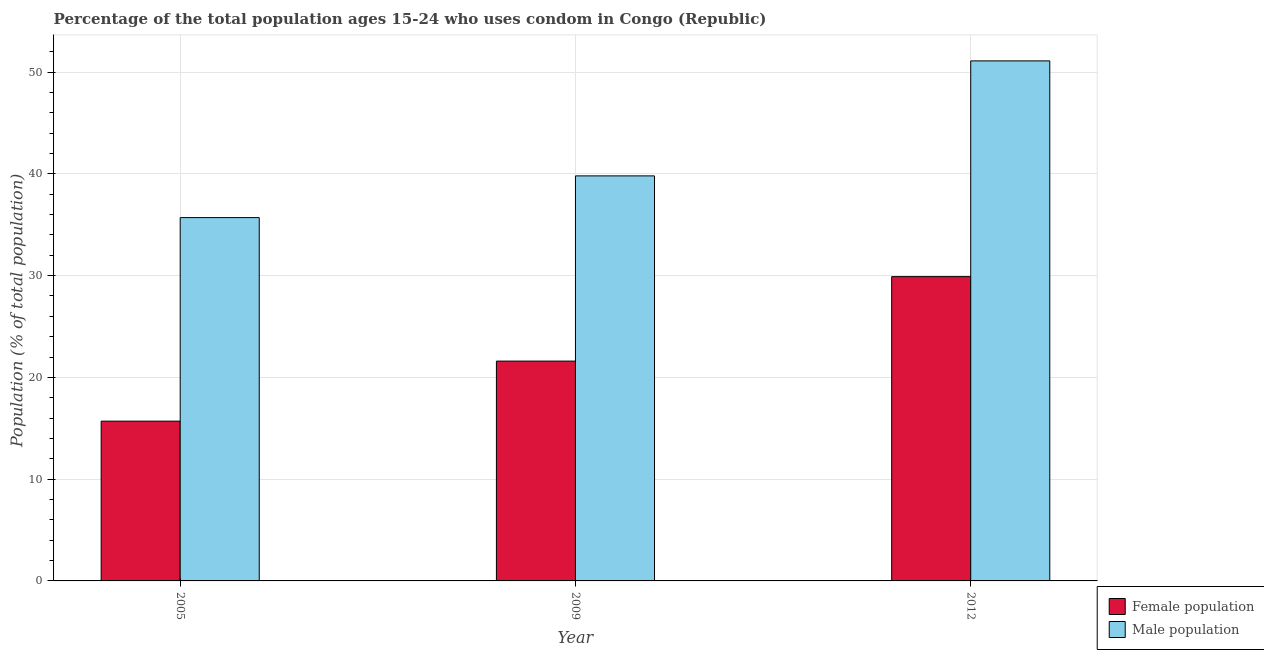How many different coloured bars are there?
Make the answer very short. 2. How many groups of bars are there?
Make the answer very short. 3. Are the number of bars per tick equal to the number of legend labels?
Ensure brevity in your answer.  Yes. Are the number of bars on each tick of the X-axis equal?
Your answer should be compact. Yes. How many bars are there on the 1st tick from the right?
Your answer should be very brief. 2. What is the male population in 2005?
Your answer should be very brief. 35.7. Across all years, what is the maximum female population?
Your response must be concise. 29.9. Across all years, what is the minimum male population?
Offer a terse response. 35.7. What is the total male population in the graph?
Your answer should be very brief. 126.6. What is the difference between the female population in 2009 and that in 2012?
Provide a succinct answer. -8.3. What is the difference between the female population in 2009 and the male population in 2005?
Offer a terse response. 5.9. What is the average male population per year?
Your answer should be compact. 42.2. In how many years, is the female population greater than 8 %?
Your answer should be very brief. 3. What is the ratio of the male population in 2005 to that in 2012?
Ensure brevity in your answer.  0.7. Is the difference between the female population in 2005 and 2009 greater than the difference between the male population in 2005 and 2009?
Give a very brief answer. No. What is the difference between the highest and the second highest male population?
Offer a terse response. 11.3. In how many years, is the male population greater than the average male population taken over all years?
Provide a short and direct response. 1. What does the 2nd bar from the left in 2012 represents?
Your answer should be compact. Male population. What does the 1st bar from the right in 2005 represents?
Give a very brief answer. Male population. How many bars are there?
Make the answer very short. 6. Are all the bars in the graph horizontal?
Your answer should be very brief. No. How many years are there in the graph?
Provide a succinct answer. 3. Are the values on the major ticks of Y-axis written in scientific E-notation?
Give a very brief answer. No. Does the graph contain any zero values?
Your answer should be compact. No. How many legend labels are there?
Your answer should be very brief. 2. How are the legend labels stacked?
Make the answer very short. Vertical. What is the title of the graph?
Offer a terse response. Percentage of the total population ages 15-24 who uses condom in Congo (Republic). What is the label or title of the X-axis?
Make the answer very short. Year. What is the label or title of the Y-axis?
Provide a short and direct response. Population (% of total population) . What is the Population (% of total population)  of Male population in 2005?
Make the answer very short. 35.7. What is the Population (% of total population)  of Female population in 2009?
Ensure brevity in your answer.  21.6. What is the Population (% of total population)  in Male population in 2009?
Offer a very short reply. 39.8. What is the Population (% of total population)  in Female population in 2012?
Provide a short and direct response. 29.9. What is the Population (% of total population)  in Male population in 2012?
Provide a succinct answer. 51.1. Across all years, what is the maximum Population (% of total population)  in Female population?
Keep it short and to the point. 29.9. Across all years, what is the maximum Population (% of total population)  of Male population?
Your answer should be very brief. 51.1. Across all years, what is the minimum Population (% of total population)  in Male population?
Provide a short and direct response. 35.7. What is the total Population (% of total population)  of Female population in the graph?
Your response must be concise. 67.2. What is the total Population (% of total population)  of Male population in the graph?
Provide a succinct answer. 126.6. What is the difference between the Population (% of total population)  of Female population in 2005 and that in 2009?
Keep it short and to the point. -5.9. What is the difference between the Population (% of total population)  of Male population in 2005 and that in 2009?
Your answer should be compact. -4.1. What is the difference between the Population (% of total population)  of Male population in 2005 and that in 2012?
Make the answer very short. -15.4. What is the difference between the Population (% of total population)  of Female population in 2005 and the Population (% of total population)  of Male population in 2009?
Provide a short and direct response. -24.1. What is the difference between the Population (% of total population)  of Female population in 2005 and the Population (% of total population)  of Male population in 2012?
Your answer should be very brief. -35.4. What is the difference between the Population (% of total population)  of Female population in 2009 and the Population (% of total population)  of Male population in 2012?
Give a very brief answer. -29.5. What is the average Population (% of total population)  in Female population per year?
Your answer should be very brief. 22.4. What is the average Population (% of total population)  in Male population per year?
Your answer should be compact. 42.2. In the year 2005, what is the difference between the Population (% of total population)  of Female population and Population (% of total population)  of Male population?
Provide a short and direct response. -20. In the year 2009, what is the difference between the Population (% of total population)  in Female population and Population (% of total population)  in Male population?
Offer a very short reply. -18.2. In the year 2012, what is the difference between the Population (% of total population)  in Female population and Population (% of total population)  in Male population?
Provide a short and direct response. -21.2. What is the ratio of the Population (% of total population)  of Female population in 2005 to that in 2009?
Ensure brevity in your answer.  0.73. What is the ratio of the Population (% of total population)  of Male population in 2005 to that in 2009?
Provide a succinct answer. 0.9. What is the ratio of the Population (% of total population)  in Female population in 2005 to that in 2012?
Your answer should be very brief. 0.53. What is the ratio of the Population (% of total population)  of Male population in 2005 to that in 2012?
Your answer should be very brief. 0.7. What is the ratio of the Population (% of total population)  in Female population in 2009 to that in 2012?
Your answer should be very brief. 0.72. What is the ratio of the Population (% of total population)  in Male population in 2009 to that in 2012?
Make the answer very short. 0.78. What is the difference between the highest and the second highest Population (% of total population)  of Male population?
Give a very brief answer. 11.3. What is the difference between the highest and the lowest Population (% of total population)  of Female population?
Provide a short and direct response. 14.2. 